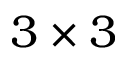<formula> <loc_0><loc_0><loc_500><loc_500>3 \times 3</formula> 